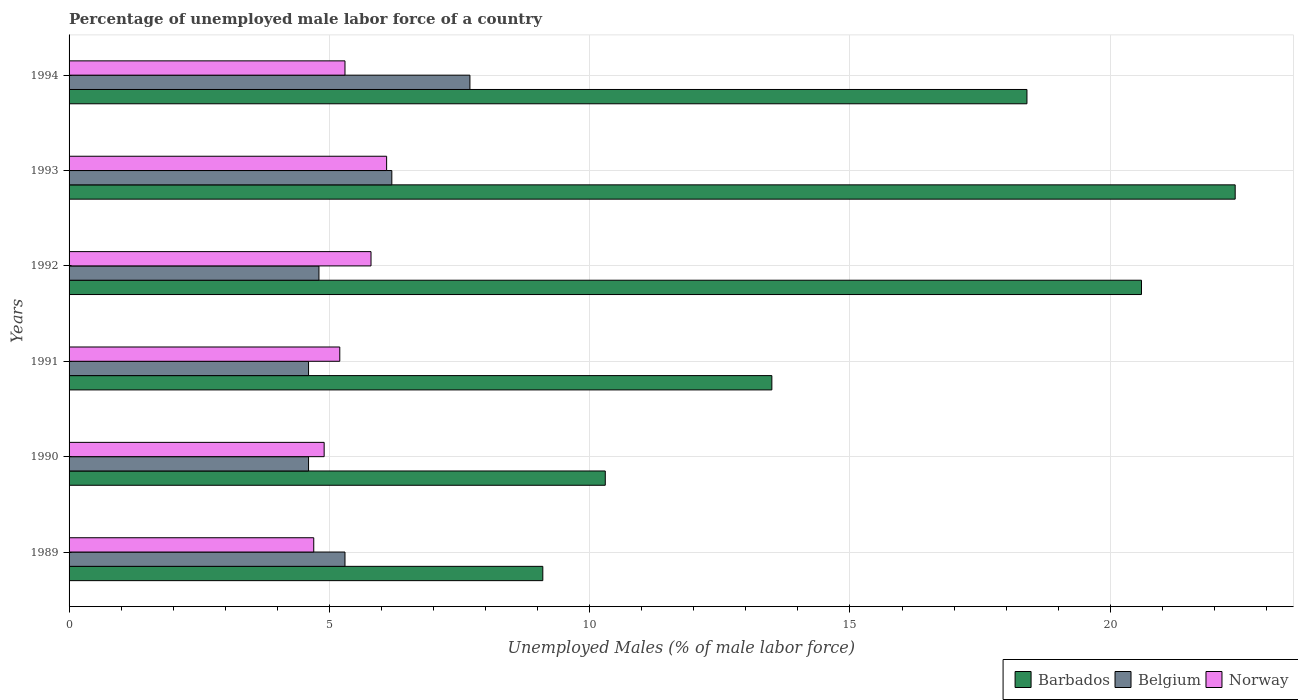How many groups of bars are there?
Provide a short and direct response. 6. How many bars are there on the 5th tick from the top?
Ensure brevity in your answer.  3. How many bars are there on the 4th tick from the bottom?
Offer a terse response. 3. What is the percentage of unemployed male labor force in Belgium in 1993?
Your response must be concise. 6.2. Across all years, what is the maximum percentage of unemployed male labor force in Norway?
Give a very brief answer. 6.1. Across all years, what is the minimum percentage of unemployed male labor force in Belgium?
Keep it short and to the point. 4.6. In which year was the percentage of unemployed male labor force in Barbados maximum?
Your answer should be very brief. 1993. What is the total percentage of unemployed male labor force in Barbados in the graph?
Your answer should be very brief. 94.3. What is the difference between the percentage of unemployed male labor force in Norway in 1990 and that in 1991?
Give a very brief answer. -0.3. What is the difference between the percentage of unemployed male labor force in Norway in 1990 and the percentage of unemployed male labor force in Belgium in 1994?
Give a very brief answer. -2.8. What is the average percentage of unemployed male labor force in Belgium per year?
Offer a very short reply. 5.53. In the year 1993, what is the difference between the percentage of unemployed male labor force in Belgium and percentage of unemployed male labor force in Norway?
Provide a short and direct response. 0.1. In how many years, is the percentage of unemployed male labor force in Belgium greater than 4 %?
Your answer should be very brief. 6. What is the ratio of the percentage of unemployed male labor force in Norway in 1993 to that in 1994?
Your response must be concise. 1.15. What is the difference between the highest and the second highest percentage of unemployed male labor force in Barbados?
Keep it short and to the point. 1.8. What is the difference between the highest and the lowest percentage of unemployed male labor force in Belgium?
Keep it short and to the point. 3.1. Is the sum of the percentage of unemployed male labor force in Barbados in 1989 and 1993 greater than the maximum percentage of unemployed male labor force in Norway across all years?
Make the answer very short. Yes. What does the 3rd bar from the top in 1992 represents?
Your answer should be very brief. Barbados. What does the 1st bar from the bottom in 1991 represents?
Provide a short and direct response. Barbados. How many years are there in the graph?
Your answer should be compact. 6. Where does the legend appear in the graph?
Keep it short and to the point. Bottom right. How many legend labels are there?
Offer a terse response. 3. What is the title of the graph?
Provide a succinct answer. Percentage of unemployed male labor force of a country. What is the label or title of the X-axis?
Provide a succinct answer. Unemployed Males (% of male labor force). What is the Unemployed Males (% of male labor force) of Barbados in 1989?
Make the answer very short. 9.1. What is the Unemployed Males (% of male labor force) in Belgium in 1989?
Ensure brevity in your answer.  5.3. What is the Unemployed Males (% of male labor force) of Norway in 1989?
Provide a short and direct response. 4.7. What is the Unemployed Males (% of male labor force) in Barbados in 1990?
Your response must be concise. 10.3. What is the Unemployed Males (% of male labor force) of Belgium in 1990?
Your answer should be compact. 4.6. What is the Unemployed Males (% of male labor force) of Norway in 1990?
Your response must be concise. 4.9. What is the Unemployed Males (% of male labor force) in Belgium in 1991?
Your answer should be very brief. 4.6. What is the Unemployed Males (% of male labor force) in Norway in 1991?
Your answer should be compact. 5.2. What is the Unemployed Males (% of male labor force) of Barbados in 1992?
Provide a succinct answer. 20.6. What is the Unemployed Males (% of male labor force) in Belgium in 1992?
Make the answer very short. 4.8. What is the Unemployed Males (% of male labor force) of Norway in 1992?
Make the answer very short. 5.8. What is the Unemployed Males (% of male labor force) of Barbados in 1993?
Make the answer very short. 22.4. What is the Unemployed Males (% of male labor force) in Belgium in 1993?
Your answer should be compact. 6.2. What is the Unemployed Males (% of male labor force) of Norway in 1993?
Make the answer very short. 6.1. What is the Unemployed Males (% of male labor force) of Barbados in 1994?
Make the answer very short. 18.4. What is the Unemployed Males (% of male labor force) of Belgium in 1994?
Ensure brevity in your answer.  7.7. What is the Unemployed Males (% of male labor force) of Norway in 1994?
Give a very brief answer. 5.3. Across all years, what is the maximum Unemployed Males (% of male labor force) of Barbados?
Give a very brief answer. 22.4. Across all years, what is the maximum Unemployed Males (% of male labor force) in Belgium?
Your answer should be very brief. 7.7. Across all years, what is the maximum Unemployed Males (% of male labor force) in Norway?
Ensure brevity in your answer.  6.1. Across all years, what is the minimum Unemployed Males (% of male labor force) of Barbados?
Give a very brief answer. 9.1. Across all years, what is the minimum Unemployed Males (% of male labor force) in Belgium?
Offer a terse response. 4.6. Across all years, what is the minimum Unemployed Males (% of male labor force) in Norway?
Your response must be concise. 4.7. What is the total Unemployed Males (% of male labor force) in Barbados in the graph?
Provide a short and direct response. 94.3. What is the total Unemployed Males (% of male labor force) in Belgium in the graph?
Ensure brevity in your answer.  33.2. What is the total Unemployed Males (% of male labor force) of Norway in the graph?
Keep it short and to the point. 32. What is the difference between the Unemployed Males (% of male labor force) of Belgium in 1989 and that in 1990?
Your answer should be compact. 0.7. What is the difference between the Unemployed Males (% of male labor force) of Barbados in 1989 and that in 1991?
Ensure brevity in your answer.  -4.4. What is the difference between the Unemployed Males (% of male labor force) of Belgium in 1989 and that in 1991?
Keep it short and to the point. 0.7. What is the difference between the Unemployed Males (% of male labor force) of Norway in 1989 and that in 1992?
Your response must be concise. -1.1. What is the difference between the Unemployed Males (% of male labor force) of Belgium in 1989 and that in 1994?
Your response must be concise. -2.4. What is the difference between the Unemployed Males (% of male labor force) of Barbados in 1990 and that in 1991?
Keep it short and to the point. -3.2. What is the difference between the Unemployed Males (% of male labor force) of Belgium in 1990 and that in 1991?
Offer a very short reply. 0. What is the difference between the Unemployed Males (% of male labor force) in Norway in 1990 and that in 1991?
Offer a very short reply. -0.3. What is the difference between the Unemployed Males (% of male labor force) in Barbados in 1990 and that in 1992?
Your answer should be compact. -10.3. What is the difference between the Unemployed Males (% of male labor force) of Belgium in 1990 and that in 1993?
Provide a short and direct response. -1.6. What is the difference between the Unemployed Males (% of male labor force) of Norway in 1990 and that in 1993?
Make the answer very short. -1.2. What is the difference between the Unemployed Males (% of male labor force) of Belgium in 1991 and that in 1992?
Ensure brevity in your answer.  -0.2. What is the difference between the Unemployed Males (% of male labor force) in Norway in 1991 and that in 1992?
Your answer should be very brief. -0.6. What is the difference between the Unemployed Males (% of male labor force) of Barbados in 1991 and that in 1993?
Offer a very short reply. -8.9. What is the difference between the Unemployed Males (% of male labor force) in Barbados in 1991 and that in 1994?
Ensure brevity in your answer.  -4.9. What is the difference between the Unemployed Males (% of male labor force) of Belgium in 1991 and that in 1994?
Provide a succinct answer. -3.1. What is the difference between the Unemployed Males (% of male labor force) of Norway in 1991 and that in 1994?
Your answer should be compact. -0.1. What is the difference between the Unemployed Males (% of male labor force) in Norway in 1992 and that in 1993?
Keep it short and to the point. -0.3. What is the difference between the Unemployed Males (% of male labor force) in Barbados in 1992 and that in 1994?
Offer a very short reply. 2.2. What is the difference between the Unemployed Males (% of male labor force) of Belgium in 1992 and that in 1994?
Make the answer very short. -2.9. What is the difference between the Unemployed Males (% of male labor force) in Barbados in 1993 and that in 1994?
Your response must be concise. 4. What is the difference between the Unemployed Males (% of male labor force) of Norway in 1993 and that in 1994?
Offer a terse response. 0.8. What is the difference between the Unemployed Males (% of male labor force) in Barbados in 1989 and the Unemployed Males (% of male labor force) in Belgium in 1990?
Make the answer very short. 4.5. What is the difference between the Unemployed Males (% of male labor force) in Barbados in 1989 and the Unemployed Males (% of male labor force) in Norway in 1990?
Your response must be concise. 4.2. What is the difference between the Unemployed Males (% of male labor force) in Belgium in 1989 and the Unemployed Males (% of male labor force) in Norway in 1990?
Your answer should be very brief. 0.4. What is the difference between the Unemployed Males (% of male labor force) in Barbados in 1989 and the Unemployed Males (% of male labor force) in Belgium in 1991?
Give a very brief answer. 4.5. What is the difference between the Unemployed Males (% of male labor force) of Barbados in 1989 and the Unemployed Males (% of male labor force) of Norway in 1991?
Give a very brief answer. 3.9. What is the difference between the Unemployed Males (% of male labor force) in Barbados in 1989 and the Unemployed Males (% of male labor force) in Belgium in 1992?
Offer a terse response. 4.3. What is the difference between the Unemployed Males (% of male labor force) in Barbados in 1989 and the Unemployed Males (% of male labor force) in Norway in 1992?
Keep it short and to the point. 3.3. What is the difference between the Unemployed Males (% of male labor force) of Belgium in 1989 and the Unemployed Males (% of male labor force) of Norway in 1992?
Provide a succinct answer. -0.5. What is the difference between the Unemployed Males (% of male labor force) of Barbados in 1989 and the Unemployed Males (% of male labor force) of Belgium in 1993?
Your answer should be very brief. 2.9. What is the difference between the Unemployed Males (% of male labor force) of Barbados in 1989 and the Unemployed Males (% of male labor force) of Norway in 1993?
Offer a terse response. 3. What is the difference between the Unemployed Males (% of male labor force) in Belgium in 1989 and the Unemployed Males (% of male labor force) in Norway in 1993?
Provide a succinct answer. -0.8. What is the difference between the Unemployed Males (% of male labor force) in Barbados in 1990 and the Unemployed Males (% of male labor force) in Belgium in 1992?
Give a very brief answer. 5.5. What is the difference between the Unemployed Males (% of male labor force) of Belgium in 1990 and the Unemployed Males (% of male labor force) of Norway in 1992?
Make the answer very short. -1.2. What is the difference between the Unemployed Males (% of male labor force) of Barbados in 1990 and the Unemployed Males (% of male labor force) of Norway in 1993?
Your response must be concise. 4.2. What is the difference between the Unemployed Males (% of male labor force) in Barbados in 1990 and the Unemployed Males (% of male labor force) in Belgium in 1994?
Offer a terse response. 2.6. What is the difference between the Unemployed Males (% of male labor force) in Barbados in 1991 and the Unemployed Males (% of male labor force) in Norway in 1992?
Your answer should be compact. 7.7. What is the difference between the Unemployed Males (% of male labor force) in Belgium in 1991 and the Unemployed Males (% of male labor force) in Norway in 1992?
Offer a very short reply. -1.2. What is the difference between the Unemployed Males (% of male labor force) of Barbados in 1991 and the Unemployed Males (% of male labor force) of Belgium in 1993?
Offer a very short reply. 7.3. What is the difference between the Unemployed Males (% of male labor force) in Belgium in 1991 and the Unemployed Males (% of male labor force) in Norway in 1993?
Provide a short and direct response. -1.5. What is the difference between the Unemployed Males (% of male labor force) of Barbados in 1991 and the Unemployed Males (% of male labor force) of Belgium in 1994?
Provide a short and direct response. 5.8. What is the difference between the Unemployed Males (% of male labor force) in Barbados in 1992 and the Unemployed Males (% of male labor force) in Norway in 1993?
Provide a short and direct response. 14.5. What is the difference between the Unemployed Males (% of male labor force) of Belgium in 1992 and the Unemployed Males (% of male labor force) of Norway in 1993?
Your answer should be very brief. -1.3. What is the difference between the Unemployed Males (% of male labor force) in Barbados in 1992 and the Unemployed Males (% of male labor force) in Belgium in 1994?
Give a very brief answer. 12.9. What is the difference between the Unemployed Males (% of male labor force) of Belgium in 1992 and the Unemployed Males (% of male labor force) of Norway in 1994?
Provide a succinct answer. -0.5. What is the difference between the Unemployed Males (% of male labor force) of Barbados in 1993 and the Unemployed Males (% of male labor force) of Belgium in 1994?
Your response must be concise. 14.7. What is the average Unemployed Males (% of male labor force) of Barbados per year?
Give a very brief answer. 15.72. What is the average Unemployed Males (% of male labor force) in Belgium per year?
Ensure brevity in your answer.  5.53. What is the average Unemployed Males (% of male labor force) of Norway per year?
Your response must be concise. 5.33. In the year 1990, what is the difference between the Unemployed Males (% of male labor force) in Barbados and Unemployed Males (% of male labor force) in Belgium?
Provide a short and direct response. 5.7. In the year 1990, what is the difference between the Unemployed Males (% of male labor force) in Belgium and Unemployed Males (% of male labor force) in Norway?
Your response must be concise. -0.3. In the year 1991, what is the difference between the Unemployed Males (% of male labor force) of Barbados and Unemployed Males (% of male labor force) of Norway?
Offer a terse response. 8.3. In the year 1992, what is the difference between the Unemployed Males (% of male labor force) in Barbados and Unemployed Males (% of male labor force) in Norway?
Your answer should be very brief. 14.8. In the year 1992, what is the difference between the Unemployed Males (% of male labor force) of Belgium and Unemployed Males (% of male labor force) of Norway?
Offer a very short reply. -1. What is the ratio of the Unemployed Males (% of male labor force) in Barbados in 1989 to that in 1990?
Offer a terse response. 0.88. What is the ratio of the Unemployed Males (% of male labor force) in Belgium in 1989 to that in 1990?
Offer a very short reply. 1.15. What is the ratio of the Unemployed Males (% of male labor force) in Norway in 1989 to that in 1990?
Your answer should be very brief. 0.96. What is the ratio of the Unemployed Males (% of male labor force) in Barbados in 1989 to that in 1991?
Provide a short and direct response. 0.67. What is the ratio of the Unemployed Males (% of male labor force) in Belgium in 1989 to that in 1991?
Ensure brevity in your answer.  1.15. What is the ratio of the Unemployed Males (% of male labor force) in Norway in 1989 to that in 1991?
Offer a very short reply. 0.9. What is the ratio of the Unemployed Males (% of male labor force) of Barbados in 1989 to that in 1992?
Provide a succinct answer. 0.44. What is the ratio of the Unemployed Males (% of male labor force) in Belgium in 1989 to that in 1992?
Your response must be concise. 1.1. What is the ratio of the Unemployed Males (% of male labor force) in Norway in 1989 to that in 1992?
Make the answer very short. 0.81. What is the ratio of the Unemployed Males (% of male labor force) in Barbados in 1989 to that in 1993?
Offer a terse response. 0.41. What is the ratio of the Unemployed Males (% of male labor force) in Belgium in 1989 to that in 1993?
Provide a succinct answer. 0.85. What is the ratio of the Unemployed Males (% of male labor force) in Norway in 1989 to that in 1993?
Provide a short and direct response. 0.77. What is the ratio of the Unemployed Males (% of male labor force) of Barbados in 1989 to that in 1994?
Make the answer very short. 0.49. What is the ratio of the Unemployed Males (% of male labor force) of Belgium in 1989 to that in 1994?
Your response must be concise. 0.69. What is the ratio of the Unemployed Males (% of male labor force) of Norway in 1989 to that in 1994?
Provide a short and direct response. 0.89. What is the ratio of the Unemployed Males (% of male labor force) of Barbados in 1990 to that in 1991?
Provide a short and direct response. 0.76. What is the ratio of the Unemployed Males (% of male labor force) of Norway in 1990 to that in 1991?
Your response must be concise. 0.94. What is the ratio of the Unemployed Males (% of male labor force) in Belgium in 1990 to that in 1992?
Ensure brevity in your answer.  0.96. What is the ratio of the Unemployed Males (% of male labor force) of Norway in 1990 to that in 1992?
Offer a terse response. 0.84. What is the ratio of the Unemployed Males (% of male labor force) of Barbados in 1990 to that in 1993?
Give a very brief answer. 0.46. What is the ratio of the Unemployed Males (% of male labor force) of Belgium in 1990 to that in 1993?
Make the answer very short. 0.74. What is the ratio of the Unemployed Males (% of male labor force) of Norway in 1990 to that in 1993?
Offer a very short reply. 0.8. What is the ratio of the Unemployed Males (% of male labor force) of Barbados in 1990 to that in 1994?
Provide a succinct answer. 0.56. What is the ratio of the Unemployed Males (% of male labor force) of Belgium in 1990 to that in 1994?
Ensure brevity in your answer.  0.6. What is the ratio of the Unemployed Males (% of male labor force) in Norway in 1990 to that in 1994?
Your answer should be compact. 0.92. What is the ratio of the Unemployed Males (% of male labor force) of Barbados in 1991 to that in 1992?
Offer a terse response. 0.66. What is the ratio of the Unemployed Males (% of male labor force) in Belgium in 1991 to that in 1992?
Provide a succinct answer. 0.96. What is the ratio of the Unemployed Males (% of male labor force) of Norway in 1991 to that in 1992?
Provide a succinct answer. 0.9. What is the ratio of the Unemployed Males (% of male labor force) of Barbados in 1991 to that in 1993?
Your response must be concise. 0.6. What is the ratio of the Unemployed Males (% of male labor force) in Belgium in 1991 to that in 1993?
Give a very brief answer. 0.74. What is the ratio of the Unemployed Males (% of male labor force) in Norway in 1991 to that in 1993?
Your answer should be compact. 0.85. What is the ratio of the Unemployed Males (% of male labor force) of Barbados in 1991 to that in 1994?
Give a very brief answer. 0.73. What is the ratio of the Unemployed Males (% of male labor force) in Belgium in 1991 to that in 1994?
Make the answer very short. 0.6. What is the ratio of the Unemployed Males (% of male labor force) of Norway in 1991 to that in 1994?
Offer a very short reply. 0.98. What is the ratio of the Unemployed Males (% of male labor force) of Barbados in 1992 to that in 1993?
Offer a terse response. 0.92. What is the ratio of the Unemployed Males (% of male labor force) in Belgium in 1992 to that in 1993?
Ensure brevity in your answer.  0.77. What is the ratio of the Unemployed Males (% of male labor force) in Norway in 1992 to that in 1993?
Your response must be concise. 0.95. What is the ratio of the Unemployed Males (% of male labor force) in Barbados in 1992 to that in 1994?
Provide a short and direct response. 1.12. What is the ratio of the Unemployed Males (% of male labor force) in Belgium in 1992 to that in 1994?
Give a very brief answer. 0.62. What is the ratio of the Unemployed Males (% of male labor force) in Norway in 1992 to that in 1994?
Keep it short and to the point. 1.09. What is the ratio of the Unemployed Males (% of male labor force) in Barbados in 1993 to that in 1994?
Your answer should be very brief. 1.22. What is the ratio of the Unemployed Males (% of male labor force) of Belgium in 1993 to that in 1994?
Offer a terse response. 0.81. What is the ratio of the Unemployed Males (% of male labor force) in Norway in 1993 to that in 1994?
Ensure brevity in your answer.  1.15. What is the difference between the highest and the second highest Unemployed Males (% of male labor force) of Belgium?
Your answer should be very brief. 1.5. What is the difference between the highest and the second highest Unemployed Males (% of male labor force) in Norway?
Offer a terse response. 0.3. What is the difference between the highest and the lowest Unemployed Males (% of male labor force) of Norway?
Offer a very short reply. 1.4. 